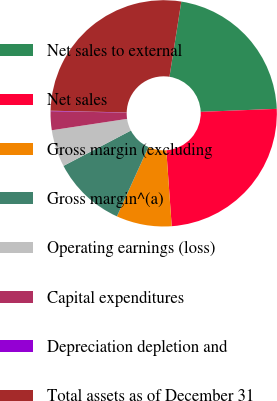<chart> <loc_0><loc_0><loc_500><loc_500><pie_chart><fcel>Net sales to external<fcel>Net sales<fcel>Gross margin (excluding<fcel>Gross margin^(a)<fcel>Operating earnings (loss)<fcel>Capital expenditures<fcel>Depreciation depletion and<fcel>Total assets as of December 31<nl><fcel>21.88%<fcel>24.5%<fcel>7.91%<fcel>10.53%<fcel>5.3%<fcel>2.69%<fcel>0.07%<fcel>27.11%<nl></chart> 